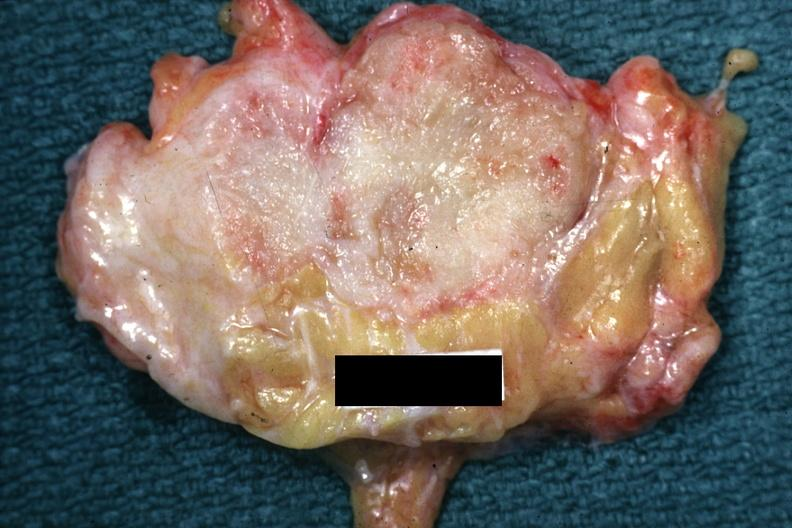what is labeled cystosarcoma?
Answer the question using a single word or phrase. Slide 